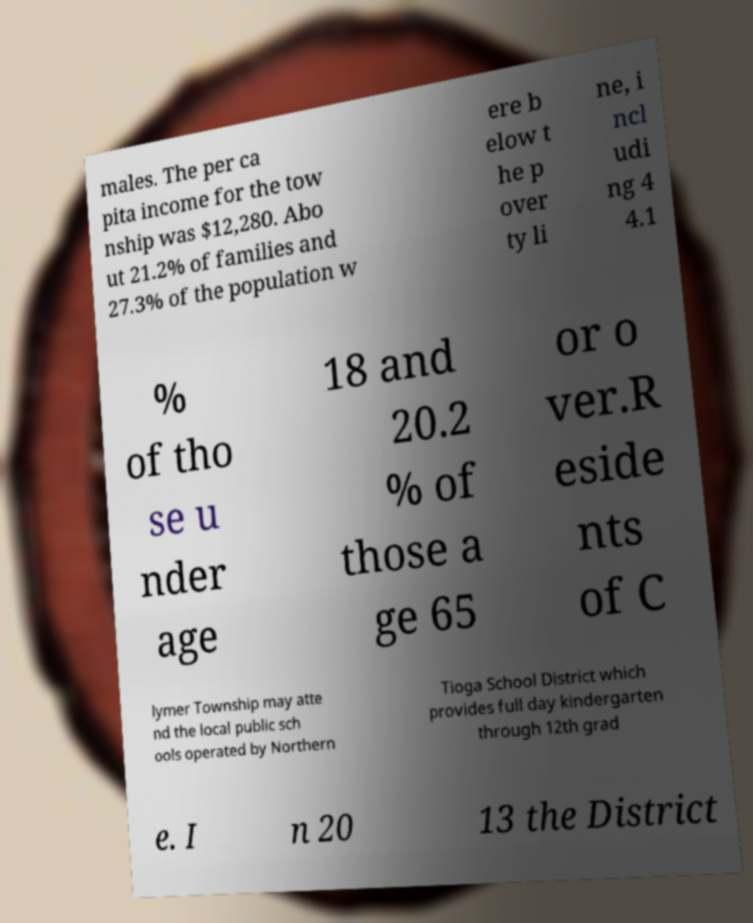For documentation purposes, I need the text within this image transcribed. Could you provide that? males. The per ca pita income for the tow nship was $12,280. Abo ut 21.2% of families and 27.3% of the population w ere b elow t he p over ty li ne, i ncl udi ng 4 4.1 % of tho se u nder age 18 and 20.2 % of those a ge 65 or o ver.R eside nts of C lymer Township may atte nd the local public sch ools operated by Northern Tioga School District which provides full day kindergarten through 12th grad e. I n 20 13 the District 